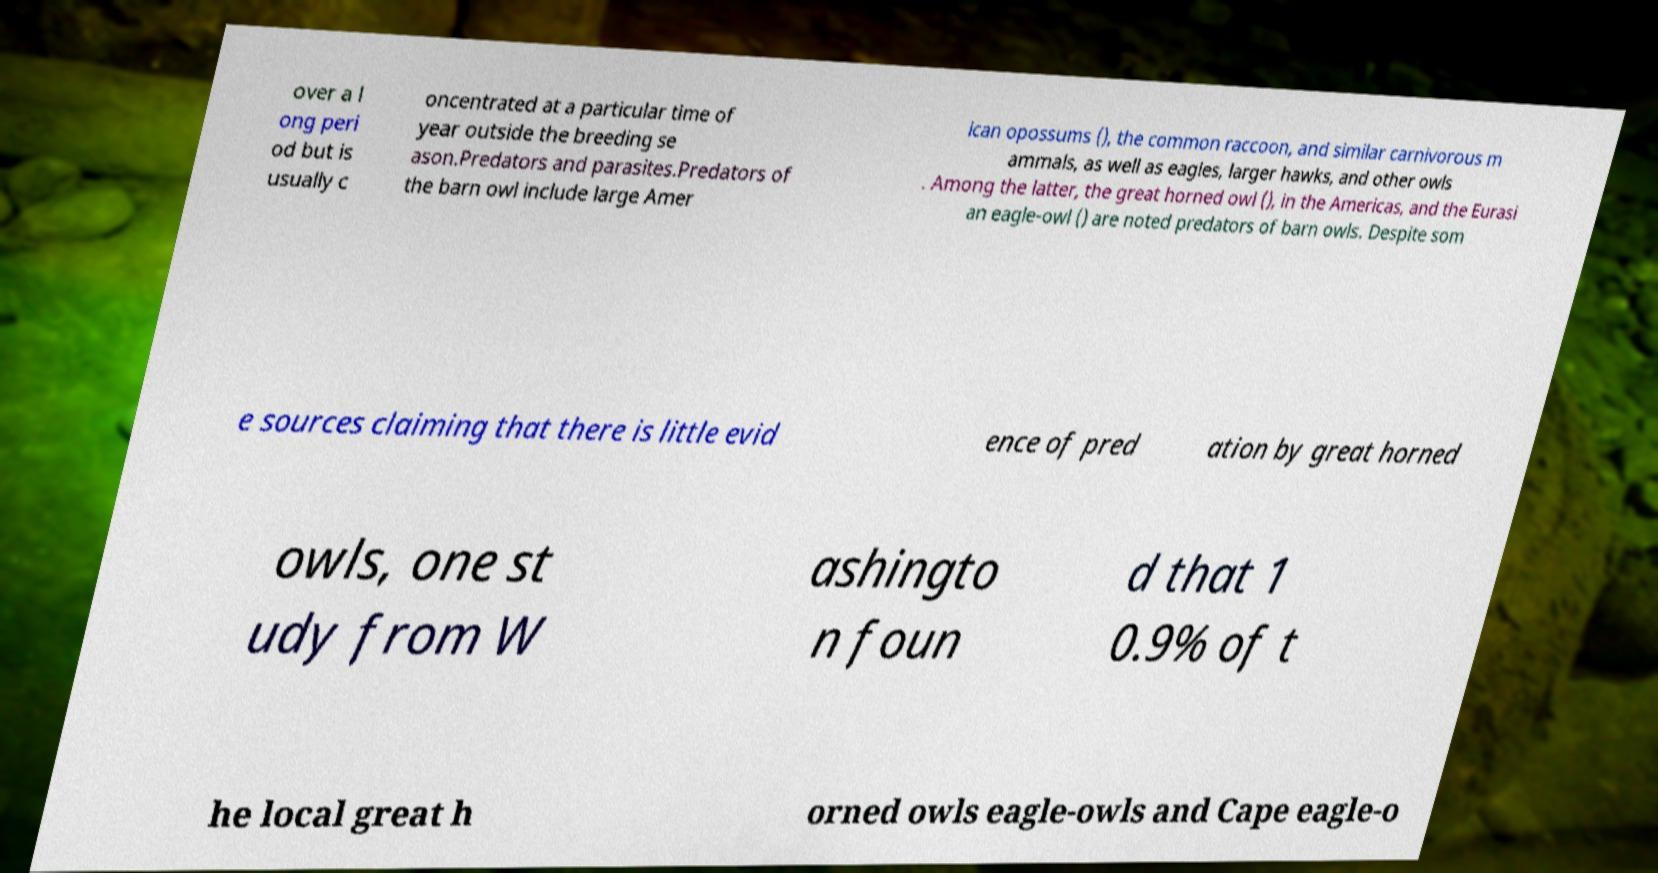Can you read and provide the text displayed in the image?This photo seems to have some interesting text. Can you extract and type it out for me? over a l ong peri od but is usually c oncentrated at a particular time of year outside the breeding se ason.Predators and parasites.Predators of the barn owl include large Amer ican opossums (), the common raccoon, and similar carnivorous m ammals, as well as eagles, larger hawks, and other owls . Among the latter, the great horned owl (), in the Americas, and the Eurasi an eagle-owl () are noted predators of barn owls. Despite som e sources claiming that there is little evid ence of pred ation by great horned owls, one st udy from W ashingto n foun d that 1 0.9% of t he local great h orned owls eagle-owls and Cape eagle-o 